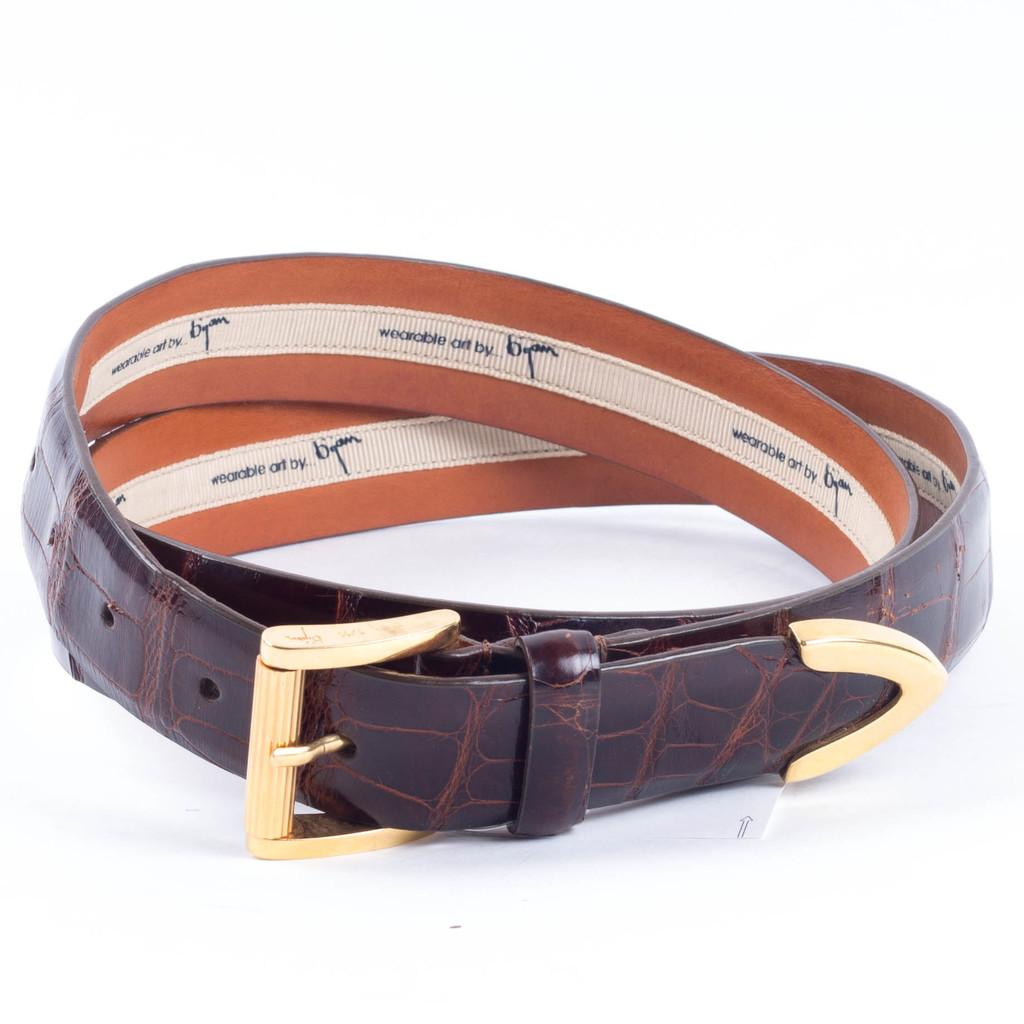What color is the belt that is visible in the image? There is a brown color belt in the image. What type of joke is being told by the belt in the image? There is no joke being told by the belt in the image, as it is an inanimate object. 